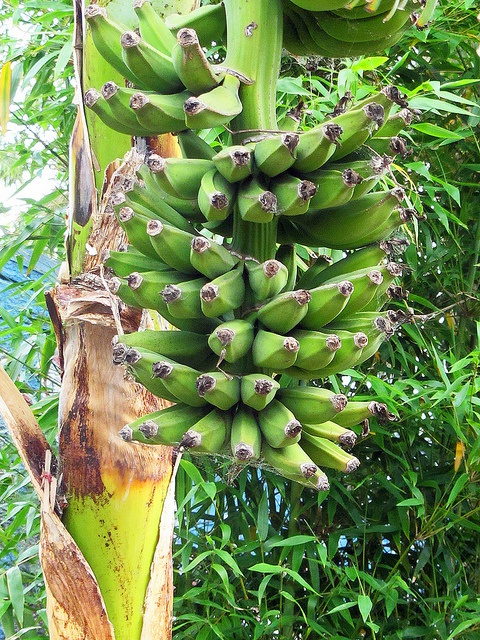Describe the objects in this image and their specific colors. I can see banana in white, darkgreen, green, and black tones and banana in white, darkgreen, black, lightgreen, and olive tones in this image. 